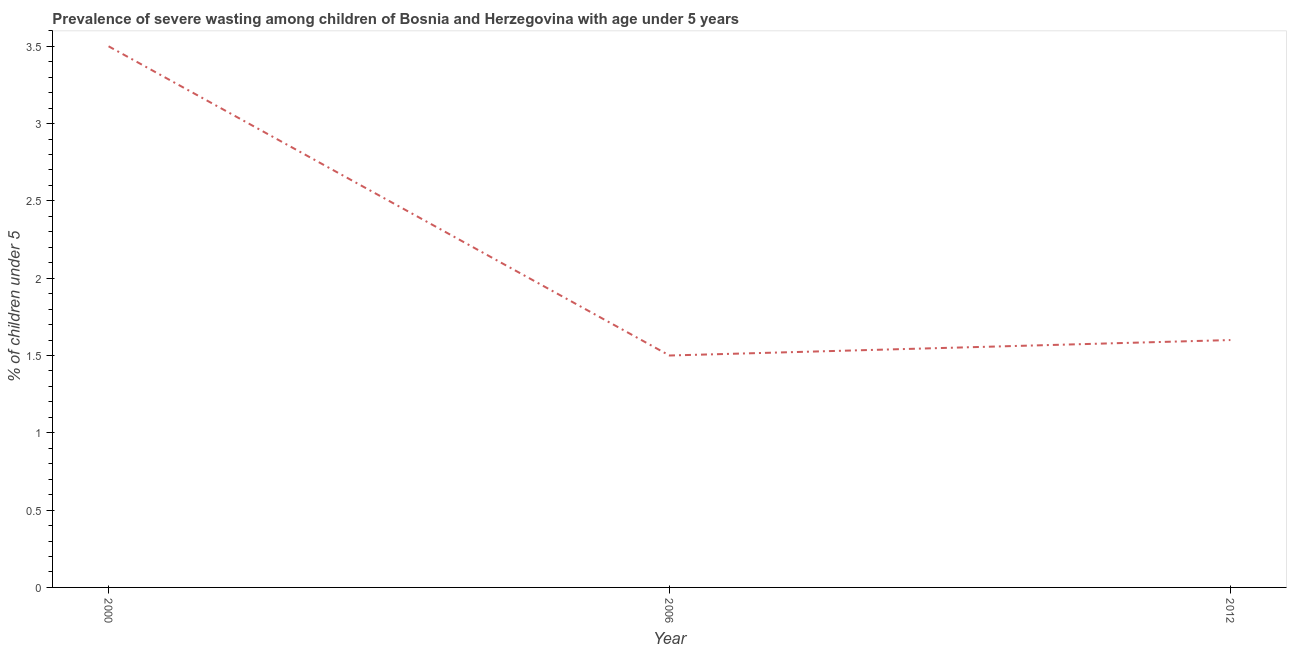What is the prevalence of severe wasting in 2000?
Offer a terse response. 3.5. Across all years, what is the maximum prevalence of severe wasting?
Offer a very short reply. 3.5. Across all years, what is the minimum prevalence of severe wasting?
Your answer should be compact. 1.5. In which year was the prevalence of severe wasting minimum?
Make the answer very short. 2006. What is the sum of the prevalence of severe wasting?
Your answer should be very brief. 6.6. What is the difference between the prevalence of severe wasting in 2000 and 2012?
Offer a very short reply. 1.9. What is the average prevalence of severe wasting per year?
Offer a very short reply. 2.2. What is the median prevalence of severe wasting?
Your response must be concise. 1.6. In how many years, is the prevalence of severe wasting greater than 3.4 %?
Give a very brief answer. 1. Do a majority of the years between 2000 and 2012 (inclusive) have prevalence of severe wasting greater than 0.1 %?
Ensure brevity in your answer.  Yes. What is the ratio of the prevalence of severe wasting in 2000 to that in 2012?
Give a very brief answer. 2.19. What is the difference between the highest and the second highest prevalence of severe wasting?
Give a very brief answer. 1.9. What is the difference between the highest and the lowest prevalence of severe wasting?
Your response must be concise. 2. In how many years, is the prevalence of severe wasting greater than the average prevalence of severe wasting taken over all years?
Offer a terse response. 1. Does the prevalence of severe wasting monotonically increase over the years?
Provide a short and direct response. No. How many years are there in the graph?
Give a very brief answer. 3. What is the difference between two consecutive major ticks on the Y-axis?
Make the answer very short. 0.5. Does the graph contain any zero values?
Provide a short and direct response. No. What is the title of the graph?
Make the answer very short. Prevalence of severe wasting among children of Bosnia and Herzegovina with age under 5 years. What is the label or title of the Y-axis?
Offer a terse response.  % of children under 5. What is the  % of children under 5 of 2012?
Make the answer very short. 1.6. What is the difference between the  % of children under 5 in 2000 and 2006?
Your answer should be very brief. 2. What is the ratio of the  % of children under 5 in 2000 to that in 2006?
Offer a terse response. 2.33. What is the ratio of the  % of children under 5 in 2000 to that in 2012?
Make the answer very short. 2.19. What is the ratio of the  % of children under 5 in 2006 to that in 2012?
Your answer should be compact. 0.94. 